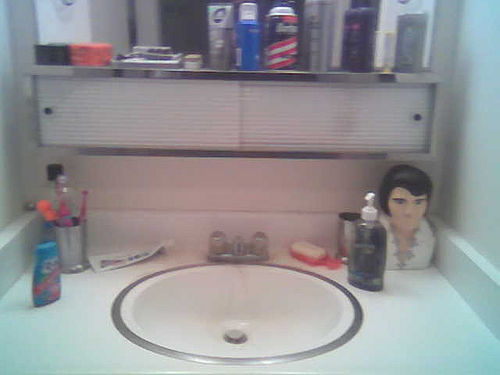<image>Is the faucet working? It is unclear if the faucet is working. It could be either working or not. Is the faucet working? I don't know if the faucet is working. It can be both working and not working. 